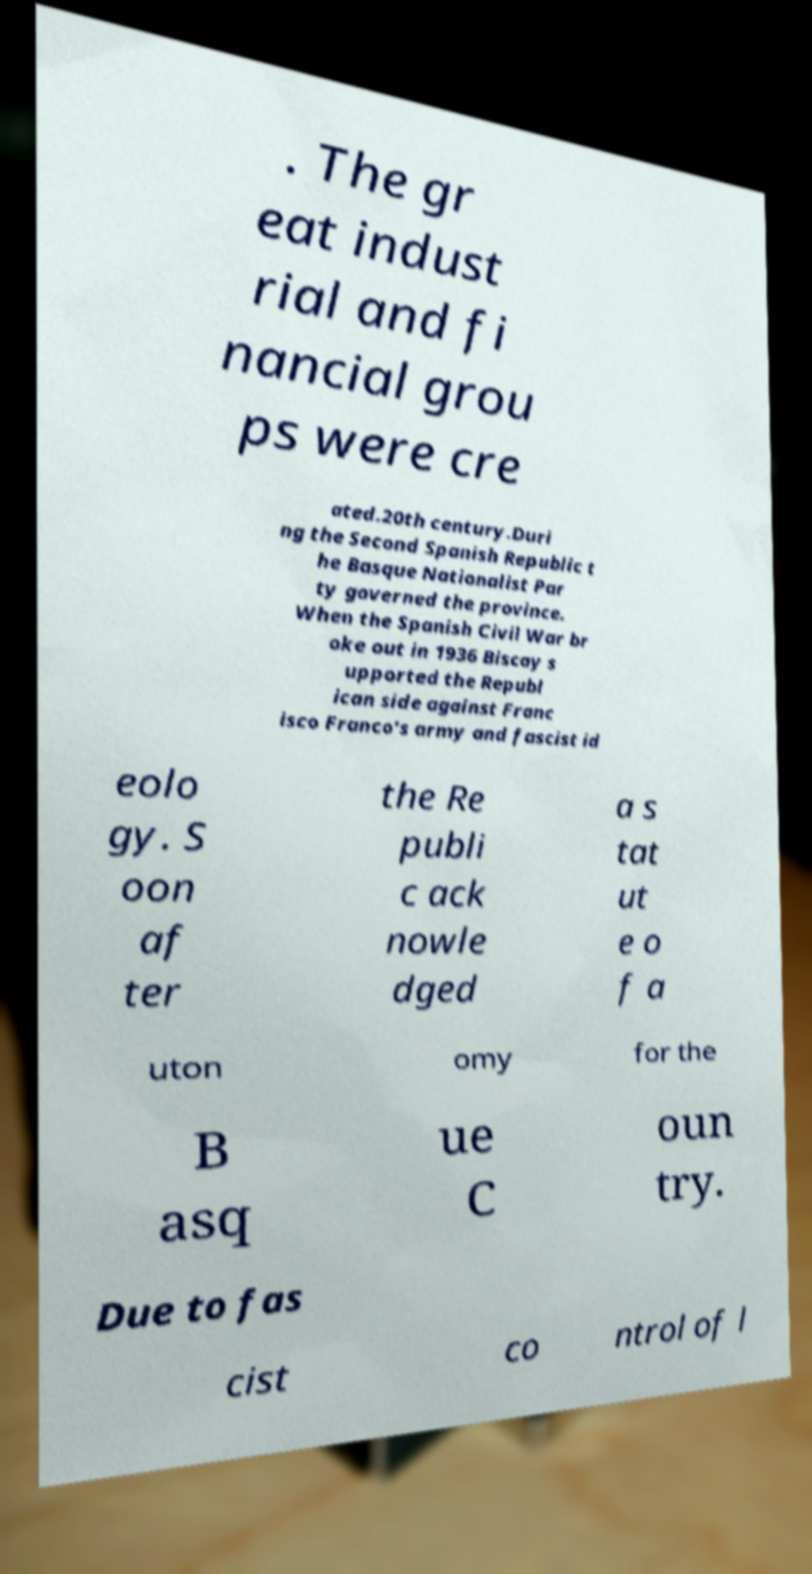Please read and relay the text visible in this image. What does it say? . The gr eat indust rial and fi nancial grou ps were cre ated.20th century.Duri ng the Second Spanish Republic t he Basque Nationalist Par ty governed the province. When the Spanish Civil War br oke out in 1936 Biscay s upported the Republ ican side against Franc isco Franco's army and fascist id eolo gy. S oon af ter the Re publi c ack nowle dged a s tat ut e o f a uton omy for the B asq ue C oun try. Due to fas cist co ntrol of l 